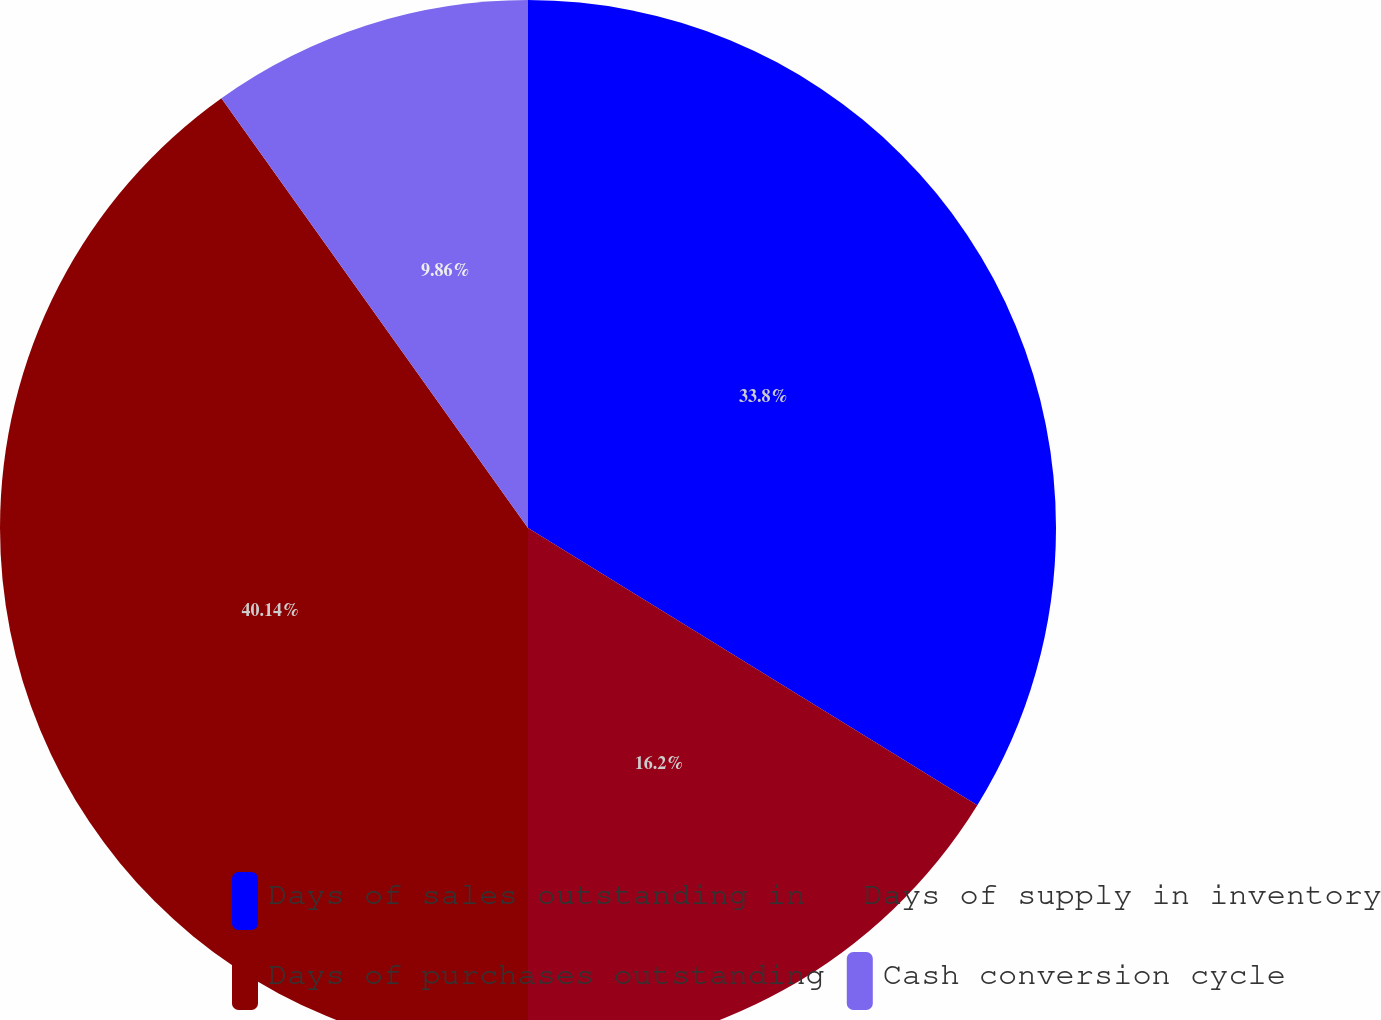Convert chart. <chart><loc_0><loc_0><loc_500><loc_500><pie_chart><fcel>Days of sales outstanding in<fcel>Days of supply in inventory<fcel>Days of purchases outstanding<fcel>Cash conversion cycle<nl><fcel>33.8%<fcel>16.2%<fcel>40.14%<fcel>9.86%<nl></chart> 